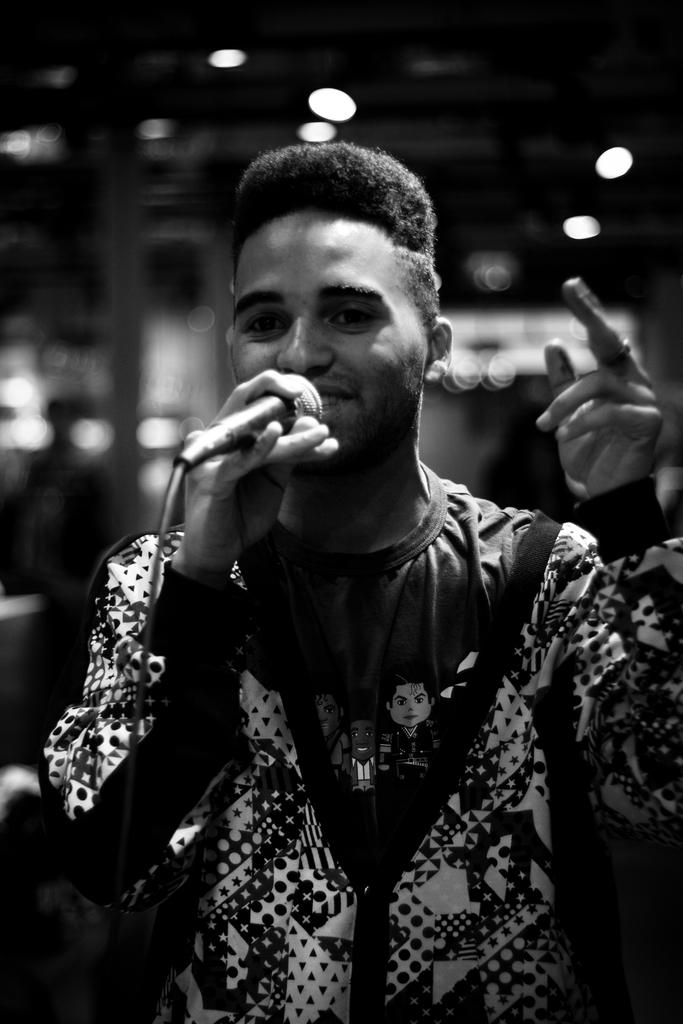What is the color scheme of the image? The image is black and white. What can be seen in the front of the image? There is a person standing in the front of the image. What is the person holding in the image? The person is holding a mic. What is visible at the top of the image? There are lights visible at the top of the image. Can you tell me how many toys are on the floor in the image? There are no toys present in the image; it features a person holding a mic in a black and white setting with lights at the top. 